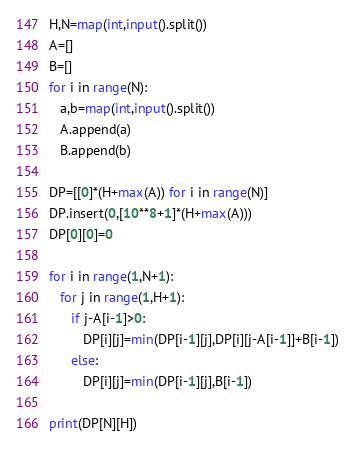Convert code to text. <code><loc_0><loc_0><loc_500><loc_500><_Python_>H,N=map(int,input().split())
A=[]
B=[]
for i in range(N):
   a,b=map(int,input().split())
   A.append(a)
   B.append(b)

DP=[[0]*(H+max(A)) for i in range(N)]
DP.insert(0,[10**8+1]*(H+max(A)))
DP[0][0]=0

for i in range(1,N+1):
   for j in range(1,H+1):
      if j-A[i-1]>0:
         DP[i][j]=min(DP[i-1][j],DP[i][j-A[i-1]]+B[i-1])
      else:
         DP[i][j]=min(DP[i-1][j],B[i-1])

print(DP[N][H])</code> 